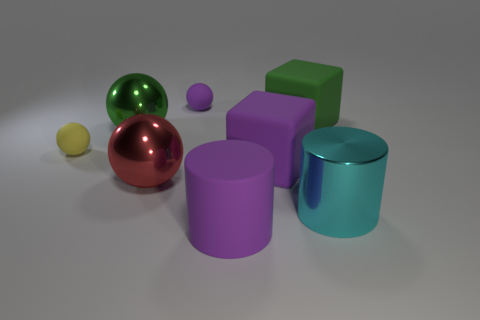Do the red metallic object and the purple cylinder have the same size?
Offer a very short reply. Yes. Are there an equal number of tiny yellow spheres that are in front of the purple rubber cube and yellow things left of the large red metallic object?
Provide a succinct answer. No. There is a big rubber thing that is in front of the big cyan cylinder; what is its shape?
Ensure brevity in your answer.  Cylinder. What shape is the green metal thing that is the same size as the red shiny thing?
Give a very brief answer. Sphere. There is a metal cylinder that is in front of the big green object on the right side of the big shiny sphere behind the small yellow object; what color is it?
Offer a terse response. Cyan. Does the tiny purple thing have the same shape as the red metal object?
Keep it short and to the point. Yes. Are there the same number of matte cylinders to the right of the green rubber cube and large green things?
Provide a short and direct response. No. What number of other objects are there of the same material as the small yellow object?
Ensure brevity in your answer.  4. There is a matte thing that is in front of the big metal cylinder; is its size the same as the green thing behind the large green metal object?
Provide a short and direct response. Yes. What number of objects are big metal things that are on the left side of the tiny purple rubber sphere or metallic spheres that are left of the red metallic ball?
Provide a succinct answer. 2. 